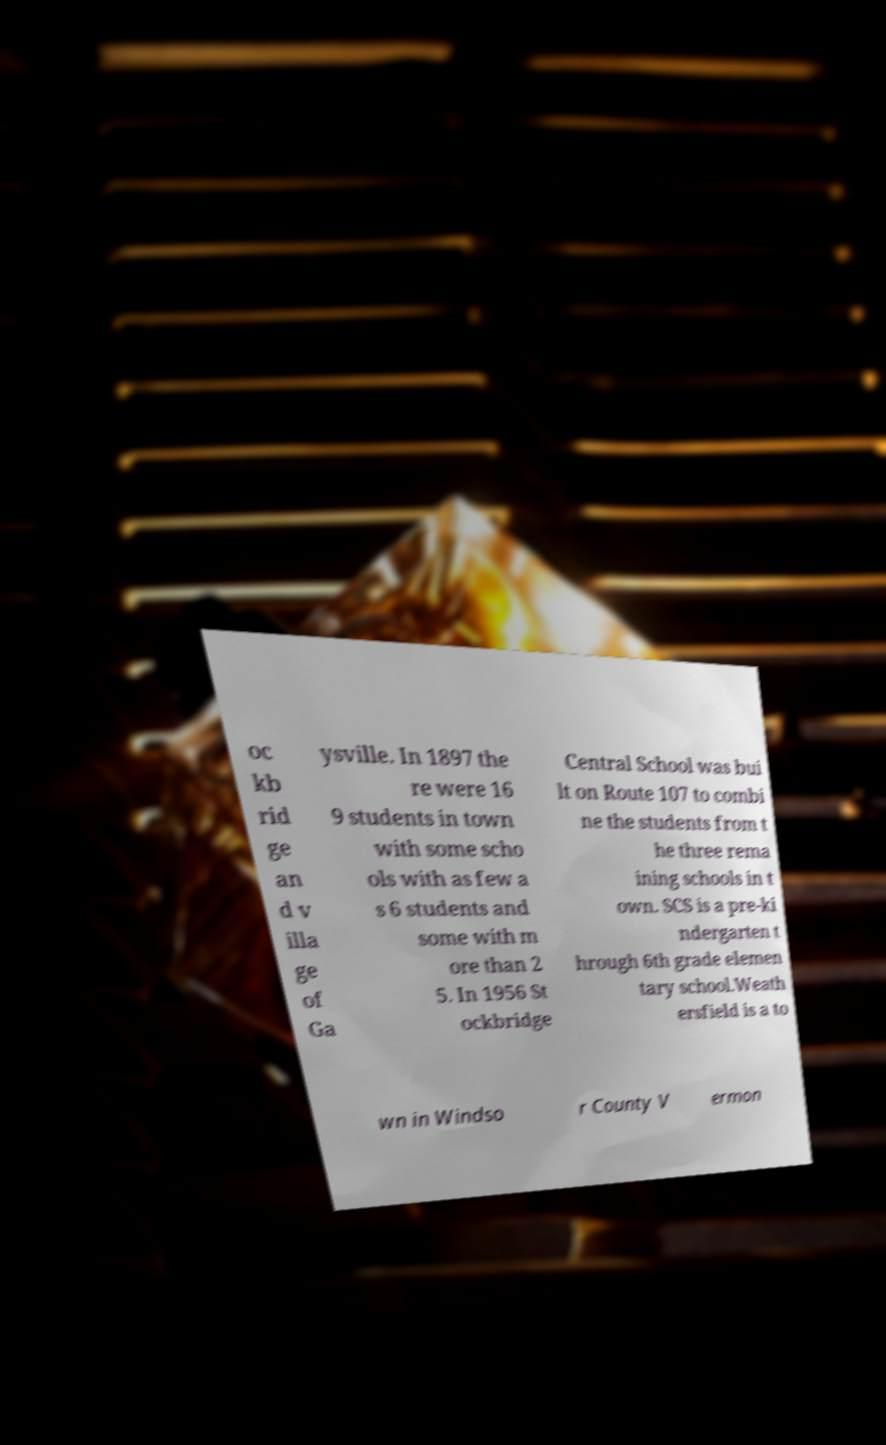Could you extract and type out the text from this image? oc kb rid ge an d v illa ge of Ga ysville. In 1897 the re were 16 9 students in town with some scho ols with as few a s 6 students and some with m ore than 2 5. In 1956 St ockbridge Central School was bui lt on Route 107 to combi ne the students from t he three rema ining schools in t own. SCS is a pre-ki ndergarten t hrough 6th grade elemen tary school.Weath ersfield is a to wn in Windso r County V ermon 